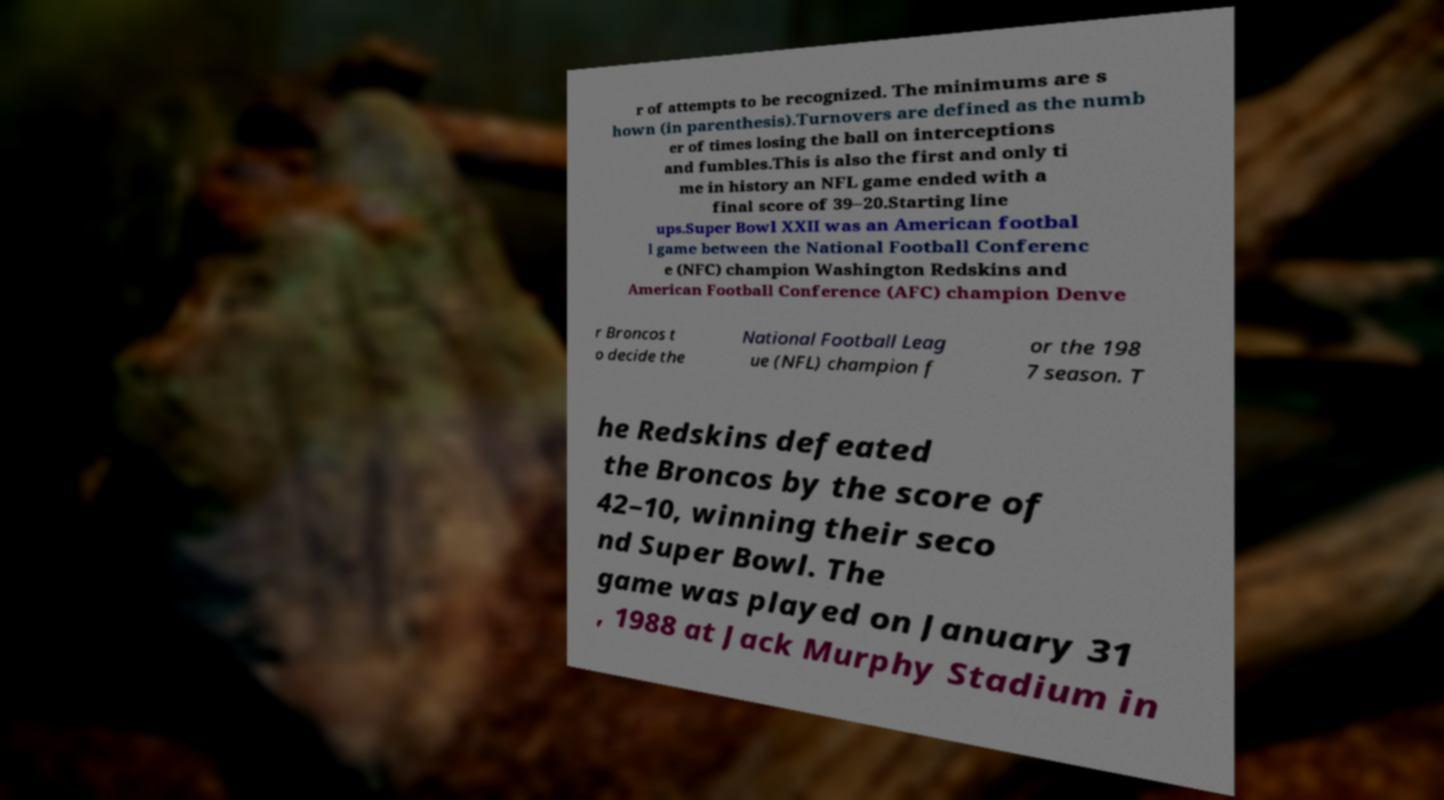What messages or text are displayed in this image? I need them in a readable, typed format. r of attempts to be recognized. The minimums are s hown (in parenthesis).Turnovers are defined as the numb er of times losing the ball on interceptions and fumbles.This is also the first and only ti me in history an NFL game ended with a final score of 39–20.Starting line ups.Super Bowl XXII was an American footbal l game between the National Football Conferenc e (NFC) champion Washington Redskins and American Football Conference (AFC) champion Denve r Broncos t o decide the National Football Leag ue (NFL) champion f or the 198 7 season. T he Redskins defeated the Broncos by the score of 42–10, winning their seco nd Super Bowl. The game was played on January 31 , 1988 at Jack Murphy Stadium in 